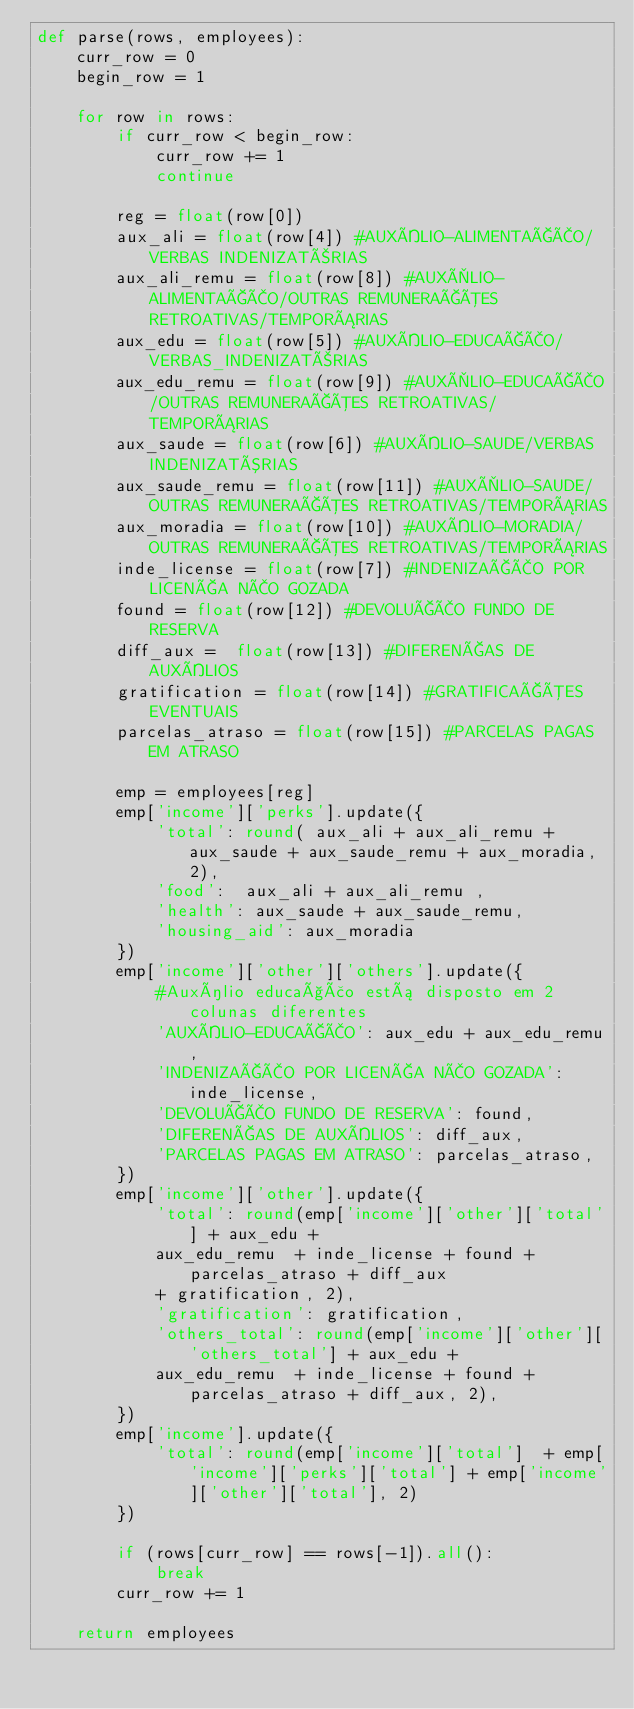Convert code to text. <code><loc_0><loc_0><loc_500><loc_500><_Python_>def parse(rows, employees):
    curr_row = 0
    begin_row = 1

    for row in rows:
        if curr_row < begin_row:
            curr_row += 1
            continue

        reg = float(row[0])
        aux_ali = float(row[4]) #AUXÍLIO-ALIMENTAÇÃO/VERBAS INDENIZATÒRIAS
        aux_ali_remu = float(row[8]) #AUXÌLIO-ALIMENTAÇÃO/OUTRAS REMUNERAÇÕES RETROATIVAS/TEMPORÁRIAS
        aux_edu = float(row[5]) #AUXÍLIO-EDUCAÇÃO/VERBAS_INDENIZATÒRIAS
        aux_edu_remu = float(row[9]) #AUXÌLIO-EDUCAÇÃO/OUTRAS REMUNERAÇÕES RETROATIVAS/TEMPORÁRIAS
        aux_saude = float(row[6]) #AUXÍLIO-SAUDE/VERBAS INDENIZATÓRIAS
        aux_saude_remu = float(row[11]) #AUXÌLIO-SAUDE/OUTRAS REMUNERAÇÕES RETROATIVAS/TEMPORÁRIAS
        aux_moradia = float(row[10]) #AUXÍLIO-MORADIA/OUTRAS REMUNERAÇÕES RETROATIVAS/TEMPORÁRIAS
        inde_license = float(row[7]) #INDENIZAÇÃO POR LICENÇA NÃO GOZADA
        found = float(row[12]) #DEVOLUÇÃO FUNDO DE RESERVA
        diff_aux =  float(row[13]) #DIFERENÇAS DE AUXÍLIOS
        gratification = float(row[14]) #GRATIFICAÇÕES EVENTUAIS
        parcelas_atraso = float(row[15]) #PARCELAS PAGAS EM ATRASO

        emp = employees[reg]
        emp['income']['perks'].update({
            'total': round( aux_ali + aux_ali_remu + aux_saude + aux_saude_remu + aux_moradia, 2),
            'food':  aux_ali + aux_ali_remu ,
            'health': aux_saude + aux_saude_remu,
            'housing_aid': aux_moradia
        })
        emp['income']['other']['others'].update({
            #Auxílio educação está disposto em 2 colunas diferentes
            'AUXÍLIO-EDUCAÇÃO': aux_edu + aux_edu_remu,
            'INDENIZAÇÃO POR LICENÇA NÃO GOZADA': inde_license,
            'DEVOLUÇÃO FUNDO DE RESERVA': found,
            'DIFERENÇAS DE AUXÍLIOS': diff_aux,
            'PARCELAS PAGAS EM ATRASO': parcelas_atraso,
        })
        emp['income']['other'].update({
            'total': round(emp['income']['other']['total'] + aux_edu +
            aux_edu_remu  + inde_license + found + parcelas_atraso + diff_aux
            + gratification, 2),
            'gratification': gratification,
            'others_total': round(emp['income']['other']['others_total'] + aux_edu +
            aux_edu_remu  + inde_license + found + parcelas_atraso + diff_aux, 2),
        })
        emp['income'].update({
            'total': round(emp['income']['total']  + emp['income']['perks']['total'] + emp['income']['other']['total'], 2)
        })
        
        if (rows[curr_row] == rows[-1]).all():
            break
        curr_row += 1

    return employees
</code> 